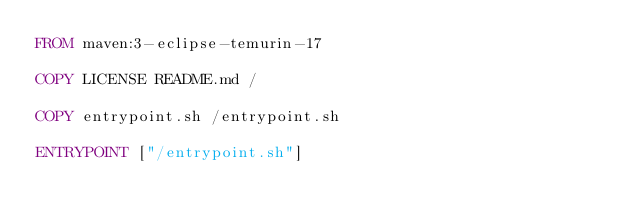<code> <loc_0><loc_0><loc_500><loc_500><_Dockerfile_>FROM maven:3-eclipse-temurin-17

COPY LICENSE README.md /

COPY entrypoint.sh /entrypoint.sh

ENTRYPOINT ["/entrypoint.sh"]
</code> 